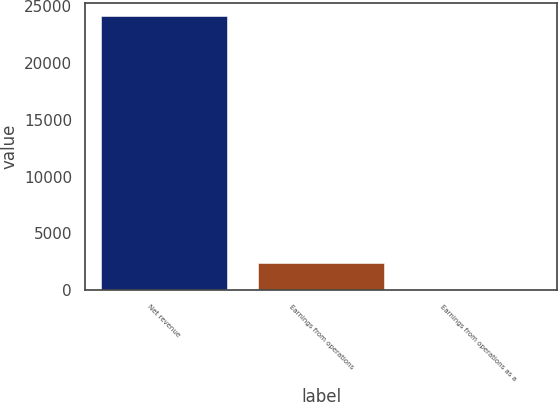<chart> <loc_0><loc_0><loc_500><loc_500><bar_chart><fcel>Net revenue<fcel>Earnings from operations<fcel>Earnings from operations as a<nl><fcel>24080<fcel>2410.97<fcel>3.3<nl></chart> 